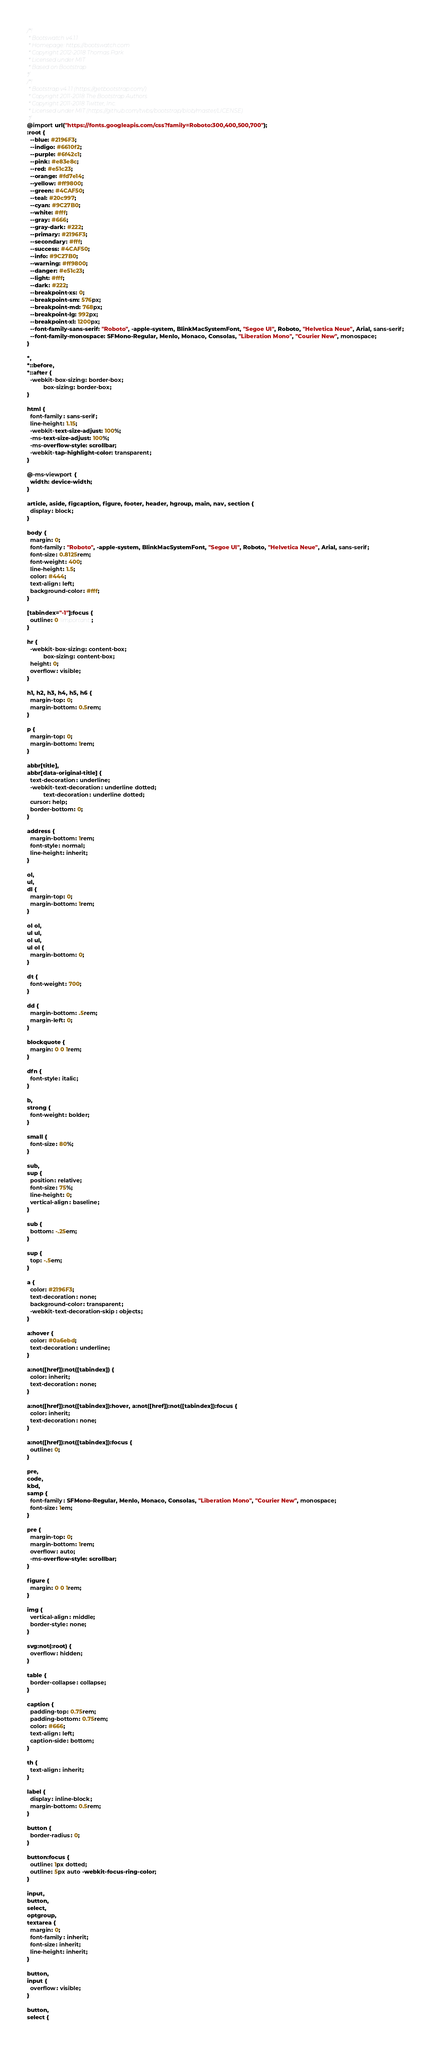Convert code to text. <code><loc_0><loc_0><loc_500><loc_500><_CSS_>/*!
 * Bootswatch v4.1.1
 * Homepage: https://bootswatch.com
 * Copyright 2012-2018 Thomas Park
 * Licensed under MIT
 * Based on Bootstrap
*/
/*!
 * Bootstrap v4.1.1 (https://getbootstrap.com/)
 * Copyright 2011-2018 The Bootstrap Authors
 * Copyright 2011-2018 Twitter, Inc.
 * Licensed under MIT (https://github.com/twbs/bootstrap/blob/master/LICENSE)
 */
@import url("https://fonts.googleapis.com/css?family=Roboto:300,400,500,700");
:root {
  --blue: #2196F3;
  --indigo: #6610f2;
  --purple: #6f42c1;
  --pink: #e83e8c;
  --red: #e51c23;
  --orange: #fd7e14;
  --yellow: #ff9800;
  --green: #4CAF50;
  --teal: #20c997;
  --cyan: #9C27B0;
  --white: #fff;
  --gray: #666;
  --gray-dark: #222;
  --primary: #2196F3;
  --secondary: #fff;
  --success: #4CAF50;
  --info: #9C27B0;
  --warning: #ff9800;
  --danger: #e51c23;
  --light: #fff;
  --dark: #222;
  --breakpoint-xs: 0;
  --breakpoint-sm: 576px;
  --breakpoint-md: 768px;
  --breakpoint-lg: 992px;
  --breakpoint-xl: 1200px;
  --font-family-sans-serif: "Roboto", -apple-system, BlinkMacSystemFont, "Segoe UI", Roboto, "Helvetica Neue", Arial, sans-serif;
  --font-family-monospace: SFMono-Regular, Menlo, Monaco, Consolas, "Liberation Mono", "Courier New", monospace;
}

*,
*::before,
*::after {
  -webkit-box-sizing: border-box;
          box-sizing: border-box;
}

html {
  font-family: sans-serif;
  line-height: 1.15;
  -webkit-text-size-adjust: 100%;
  -ms-text-size-adjust: 100%;
  -ms-overflow-style: scrollbar;
  -webkit-tap-highlight-color: transparent;
}

@-ms-viewport {
  width: device-width;
}

article, aside, figcaption, figure, footer, header, hgroup, main, nav, section {
  display: block;
}

body {
  margin: 0;
  font-family: "Roboto", -apple-system, BlinkMacSystemFont, "Segoe UI", Roboto, "Helvetica Neue", Arial, sans-serif;
  font-size: 0.8125rem;
  font-weight: 400;
  line-height: 1.5;
  color: #444;
  text-align: left;
  background-color: #fff;
}

[tabindex="-1"]:focus {
  outline: 0 !important;
}

hr {
  -webkit-box-sizing: content-box;
          box-sizing: content-box;
  height: 0;
  overflow: visible;
}

h1, h2, h3, h4, h5, h6 {
  margin-top: 0;
  margin-bottom: 0.5rem;
}

p {
  margin-top: 0;
  margin-bottom: 1rem;
}

abbr[title],
abbr[data-original-title] {
  text-decoration: underline;
  -webkit-text-decoration: underline dotted;
          text-decoration: underline dotted;
  cursor: help;
  border-bottom: 0;
}

address {
  margin-bottom: 1rem;
  font-style: normal;
  line-height: inherit;
}

ol,
ul,
dl {
  margin-top: 0;
  margin-bottom: 1rem;
}

ol ol,
ul ul,
ol ul,
ul ol {
  margin-bottom: 0;
}

dt {
  font-weight: 700;
}

dd {
  margin-bottom: .5rem;
  margin-left: 0;
}

blockquote {
  margin: 0 0 1rem;
}

dfn {
  font-style: italic;
}

b,
strong {
  font-weight: bolder;
}

small {
  font-size: 80%;
}

sub,
sup {
  position: relative;
  font-size: 75%;
  line-height: 0;
  vertical-align: baseline;
}

sub {
  bottom: -.25em;
}

sup {
  top: -.5em;
}

a {
  color: #2196F3;
  text-decoration: none;
  background-color: transparent;
  -webkit-text-decoration-skip: objects;
}

a:hover {
  color: #0a6ebd;
  text-decoration: underline;
}

a:not([href]):not([tabindex]) {
  color: inherit;
  text-decoration: none;
}

a:not([href]):not([tabindex]):hover, a:not([href]):not([tabindex]):focus {
  color: inherit;
  text-decoration: none;
}

a:not([href]):not([tabindex]):focus {
  outline: 0;
}

pre,
code,
kbd,
samp {
  font-family: SFMono-Regular, Menlo, Monaco, Consolas, "Liberation Mono", "Courier New", monospace;
  font-size: 1em;
}

pre {
  margin-top: 0;
  margin-bottom: 1rem;
  overflow: auto;
  -ms-overflow-style: scrollbar;
}

figure {
  margin: 0 0 1rem;
}

img {
  vertical-align: middle;
  border-style: none;
}

svg:not(:root) {
  overflow: hidden;
}

table {
  border-collapse: collapse;
}

caption {
  padding-top: 0.75rem;
  padding-bottom: 0.75rem;
  color: #666;
  text-align: left;
  caption-side: bottom;
}

th {
  text-align: inherit;
}

label {
  display: inline-block;
  margin-bottom: 0.5rem;
}

button {
  border-radius: 0;
}

button:focus {
  outline: 1px dotted;
  outline: 5px auto -webkit-focus-ring-color;
}

input,
button,
select,
optgroup,
textarea {
  margin: 0;
  font-family: inherit;
  font-size: inherit;
  line-height: inherit;
}

button,
input {
  overflow: visible;
}

button,
select {</code> 